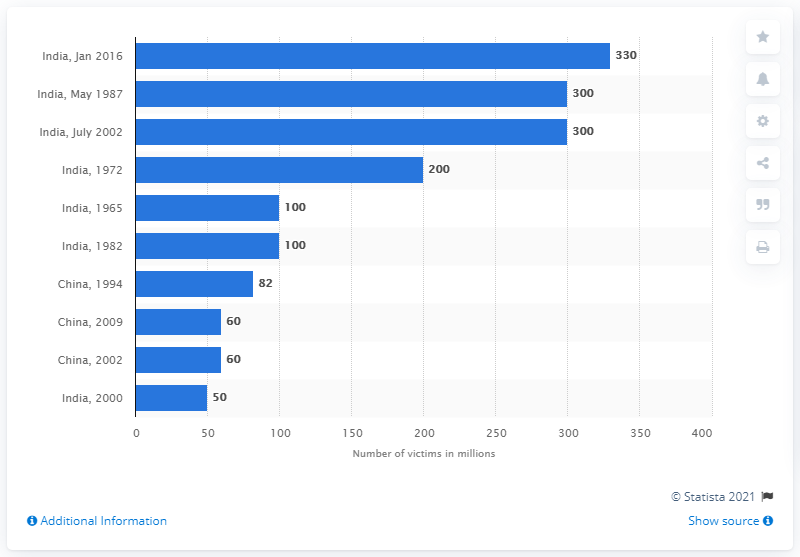Give some essential details in this illustration. During the drought in India in 1987, an estimated 300 people were affected. 